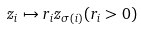<formula> <loc_0><loc_0><loc_500><loc_500>z _ { i } \mapsto r _ { i } z _ { \sigma ( i ) } ( r _ { i } > 0 )</formula> 